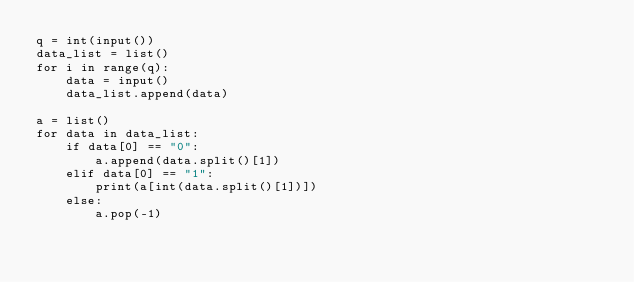Convert code to text. <code><loc_0><loc_0><loc_500><loc_500><_Python_>q = int(input())
data_list = list()
for i in range(q):
    data = input()
    data_list.append(data)

a = list()
for data in data_list:
    if data[0] == "0":
        a.append(data.split()[1])
    elif data[0] == "1":
        print(a[int(data.split()[1])])
    else:
        a.pop(-1)

</code> 